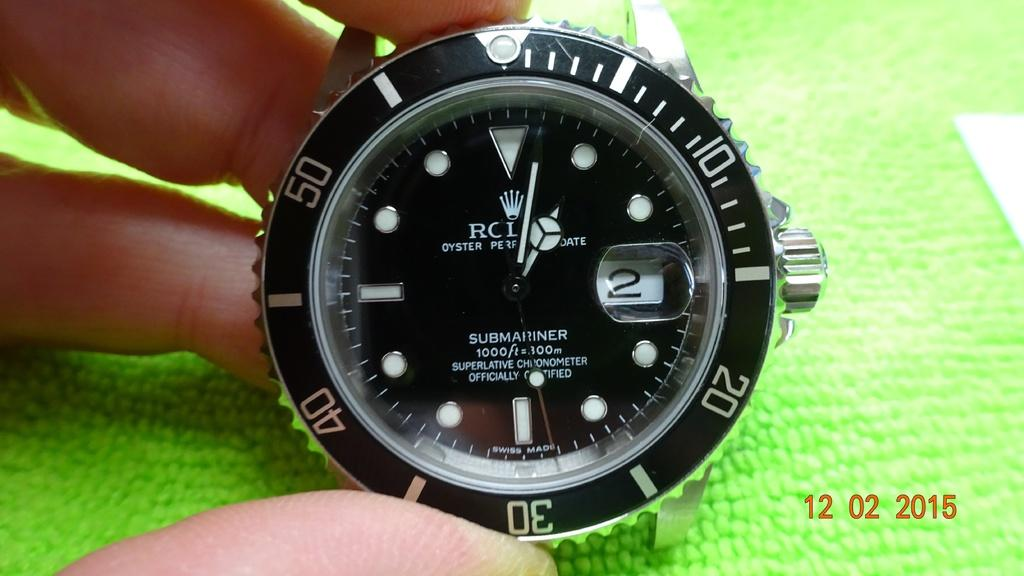Provide a one-sentence caption for the provided image. A picture of an RCI Oyster watch was taken in 2015. 